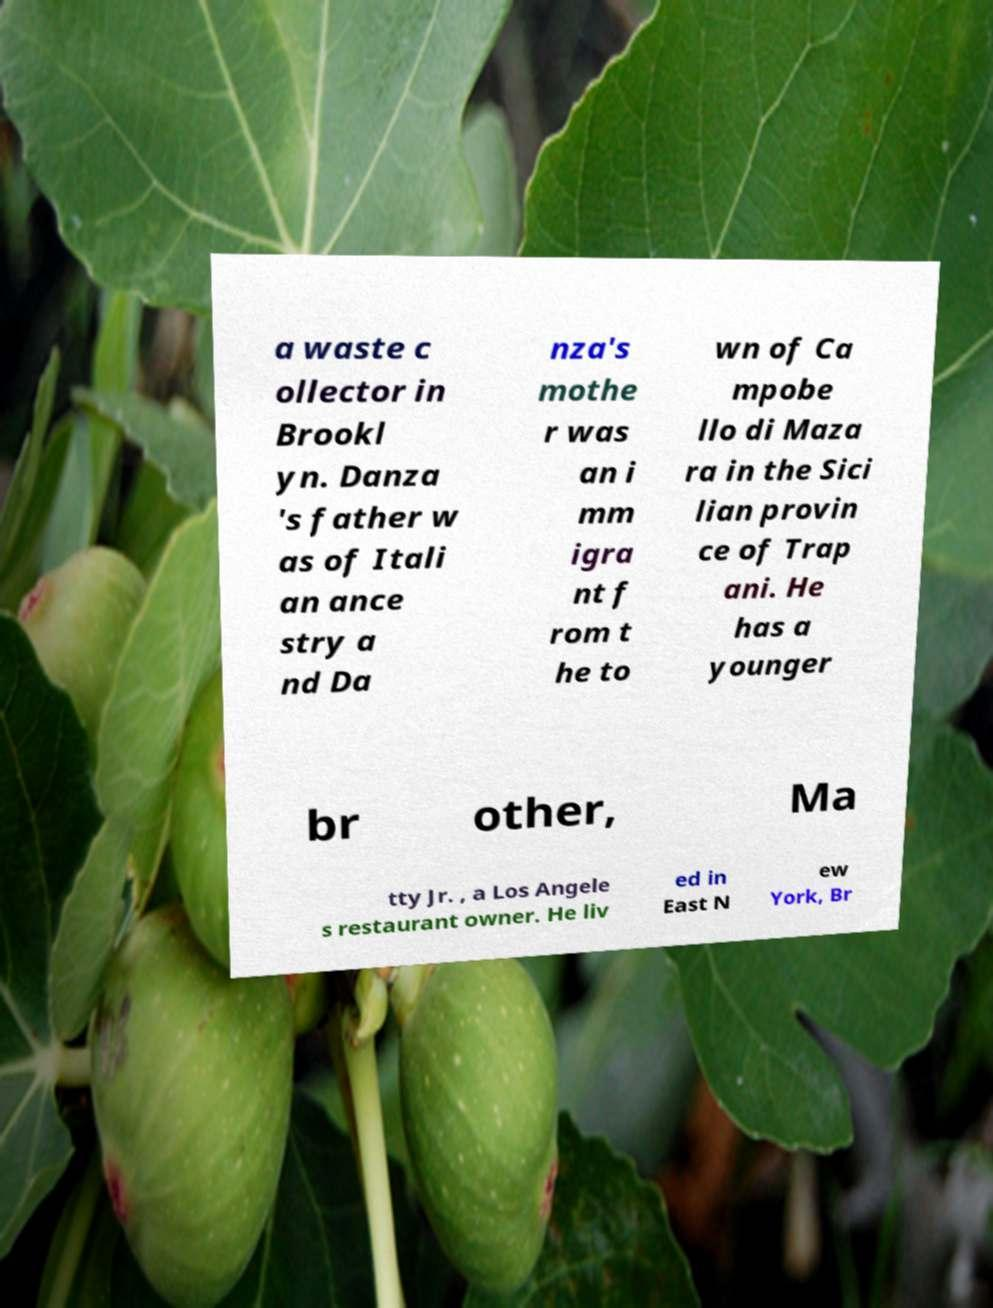What messages or text are displayed in this image? I need them in a readable, typed format. a waste c ollector in Brookl yn. Danza 's father w as of Itali an ance stry a nd Da nza's mothe r was an i mm igra nt f rom t he to wn of Ca mpobe llo di Maza ra in the Sici lian provin ce of Trap ani. He has a younger br other, Ma tty Jr. , a Los Angele s restaurant owner. He liv ed in East N ew York, Br 